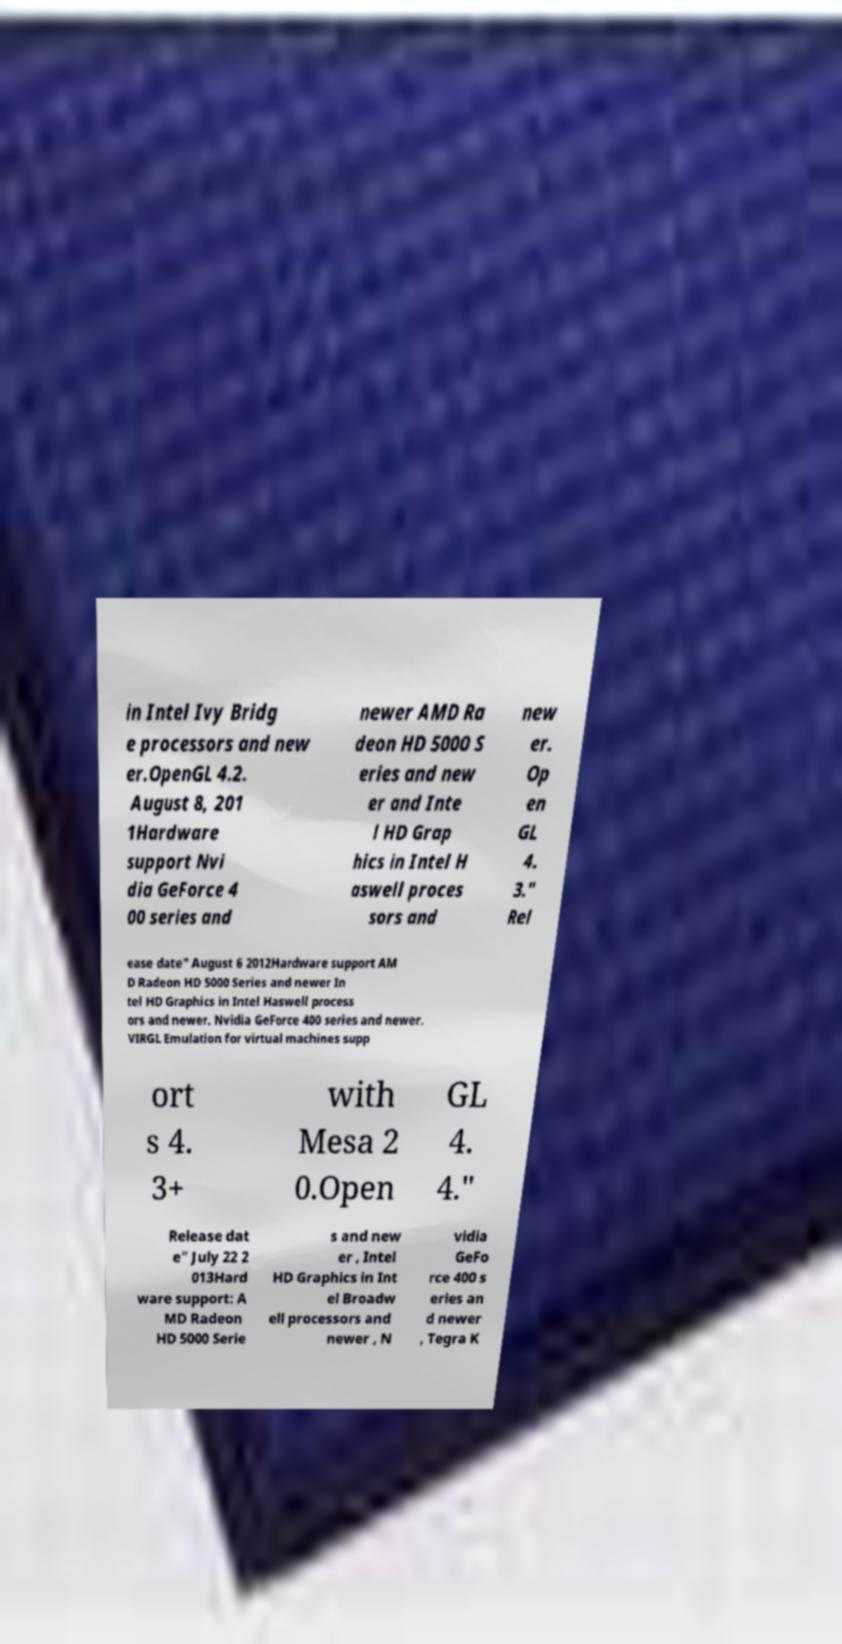For documentation purposes, I need the text within this image transcribed. Could you provide that? in Intel Ivy Bridg e processors and new er.OpenGL 4.2. August 8, 201 1Hardware support Nvi dia GeForce 4 00 series and newer AMD Ra deon HD 5000 S eries and new er and Inte l HD Grap hics in Intel H aswell proces sors and new er. Op en GL 4. 3." Rel ease date" August 6 2012Hardware support AM D Radeon HD 5000 Series and newer In tel HD Graphics in Intel Haswell process ors and newer. Nvidia GeForce 400 series and newer. VIRGL Emulation for virtual machines supp ort s 4. 3+ with Mesa 2 0.Open GL 4. 4." Release dat e" July 22 2 013Hard ware support: A MD Radeon HD 5000 Serie s and new er , Intel HD Graphics in Int el Broadw ell processors and newer , N vidia GeFo rce 400 s eries an d newer , Tegra K 